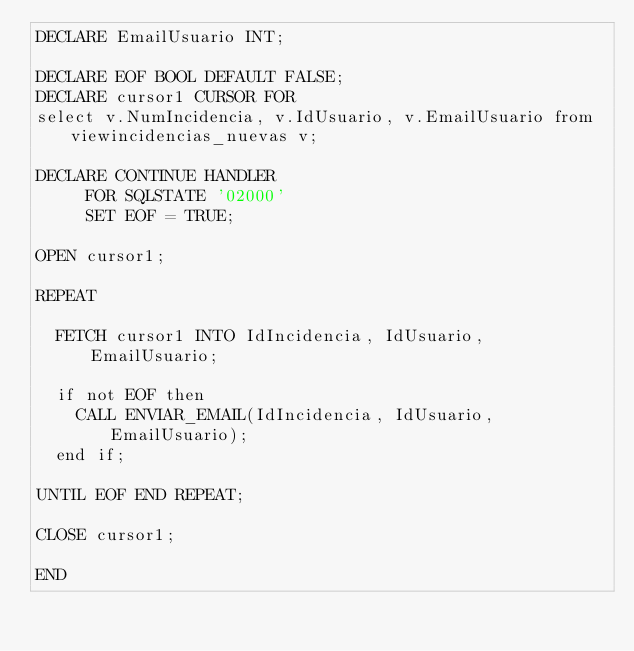<code> <loc_0><loc_0><loc_500><loc_500><_SQL_>DECLARE EmailUsuario INT;

DECLARE EOF BOOL DEFAULT FALSE;
DECLARE cursor1 CURSOR FOR 
select v.NumIncidencia, v.IdUsuario, v.EmailUsuario from viewincidencias_nuevas v;

DECLARE CONTINUE HANDLER
     FOR SQLSTATE '02000'
     SET EOF = TRUE;

OPEN cursor1;

REPEAT

	FETCH cursor1 INTO IdIncidencia, IdUsuario, EmailUsuario;
	
	if not EOF then
		CALL ENVIAR_EMAIL(IdIncidencia, IdUsuario,EmailUsuario);
	end if;

UNTIL EOF END REPEAT;

CLOSE cursor1;

END
</code> 